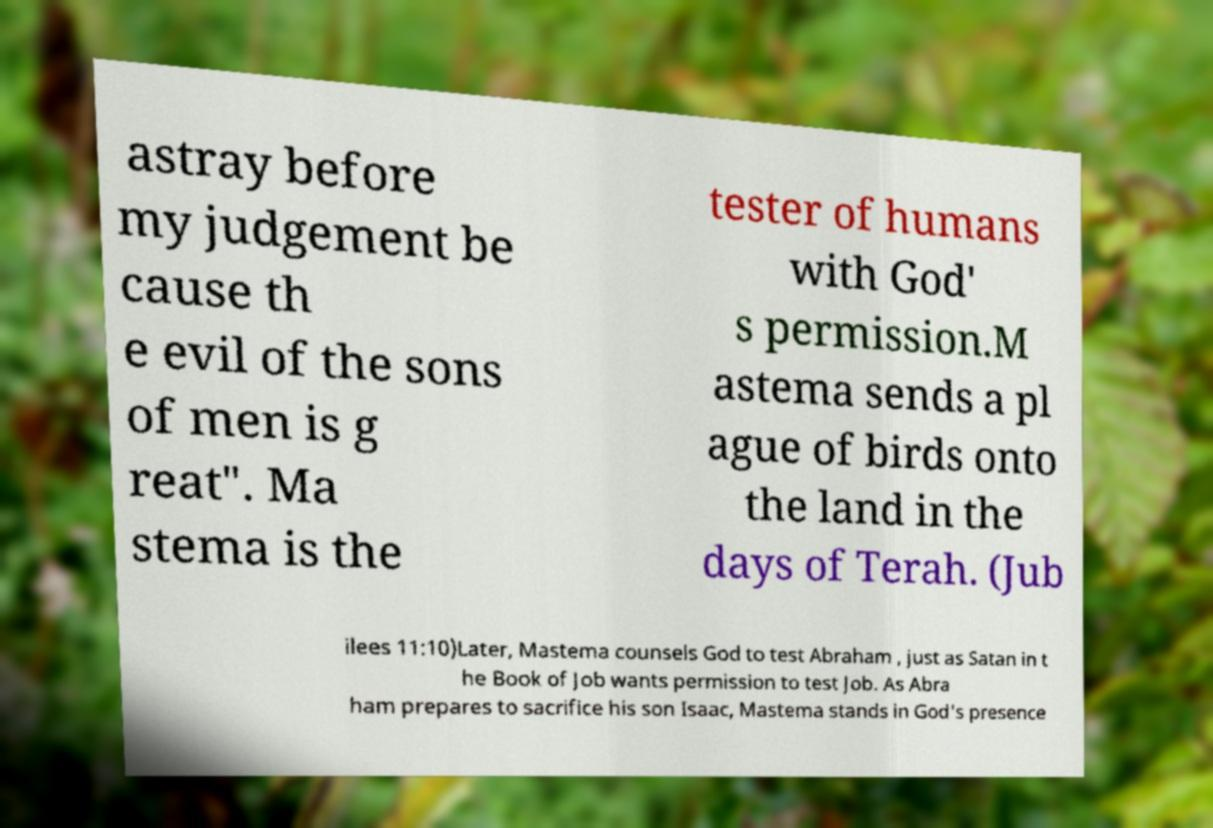Please read and relay the text visible in this image. What does it say? astray before my judgement be cause th e evil of the sons of men is g reat". Ma stema is the tester of humans with God' s permission.M astema sends a pl ague of birds onto the land in the days of Terah. (Jub ilees 11:10)Later, Mastema counsels God to test Abraham , just as Satan in t he Book of Job wants permission to test Job. As Abra ham prepares to sacrifice his son Isaac, Mastema stands in God's presence 